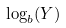Convert formula to latex. <formula><loc_0><loc_0><loc_500><loc_500>\log _ { b } ( Y )</formula> 